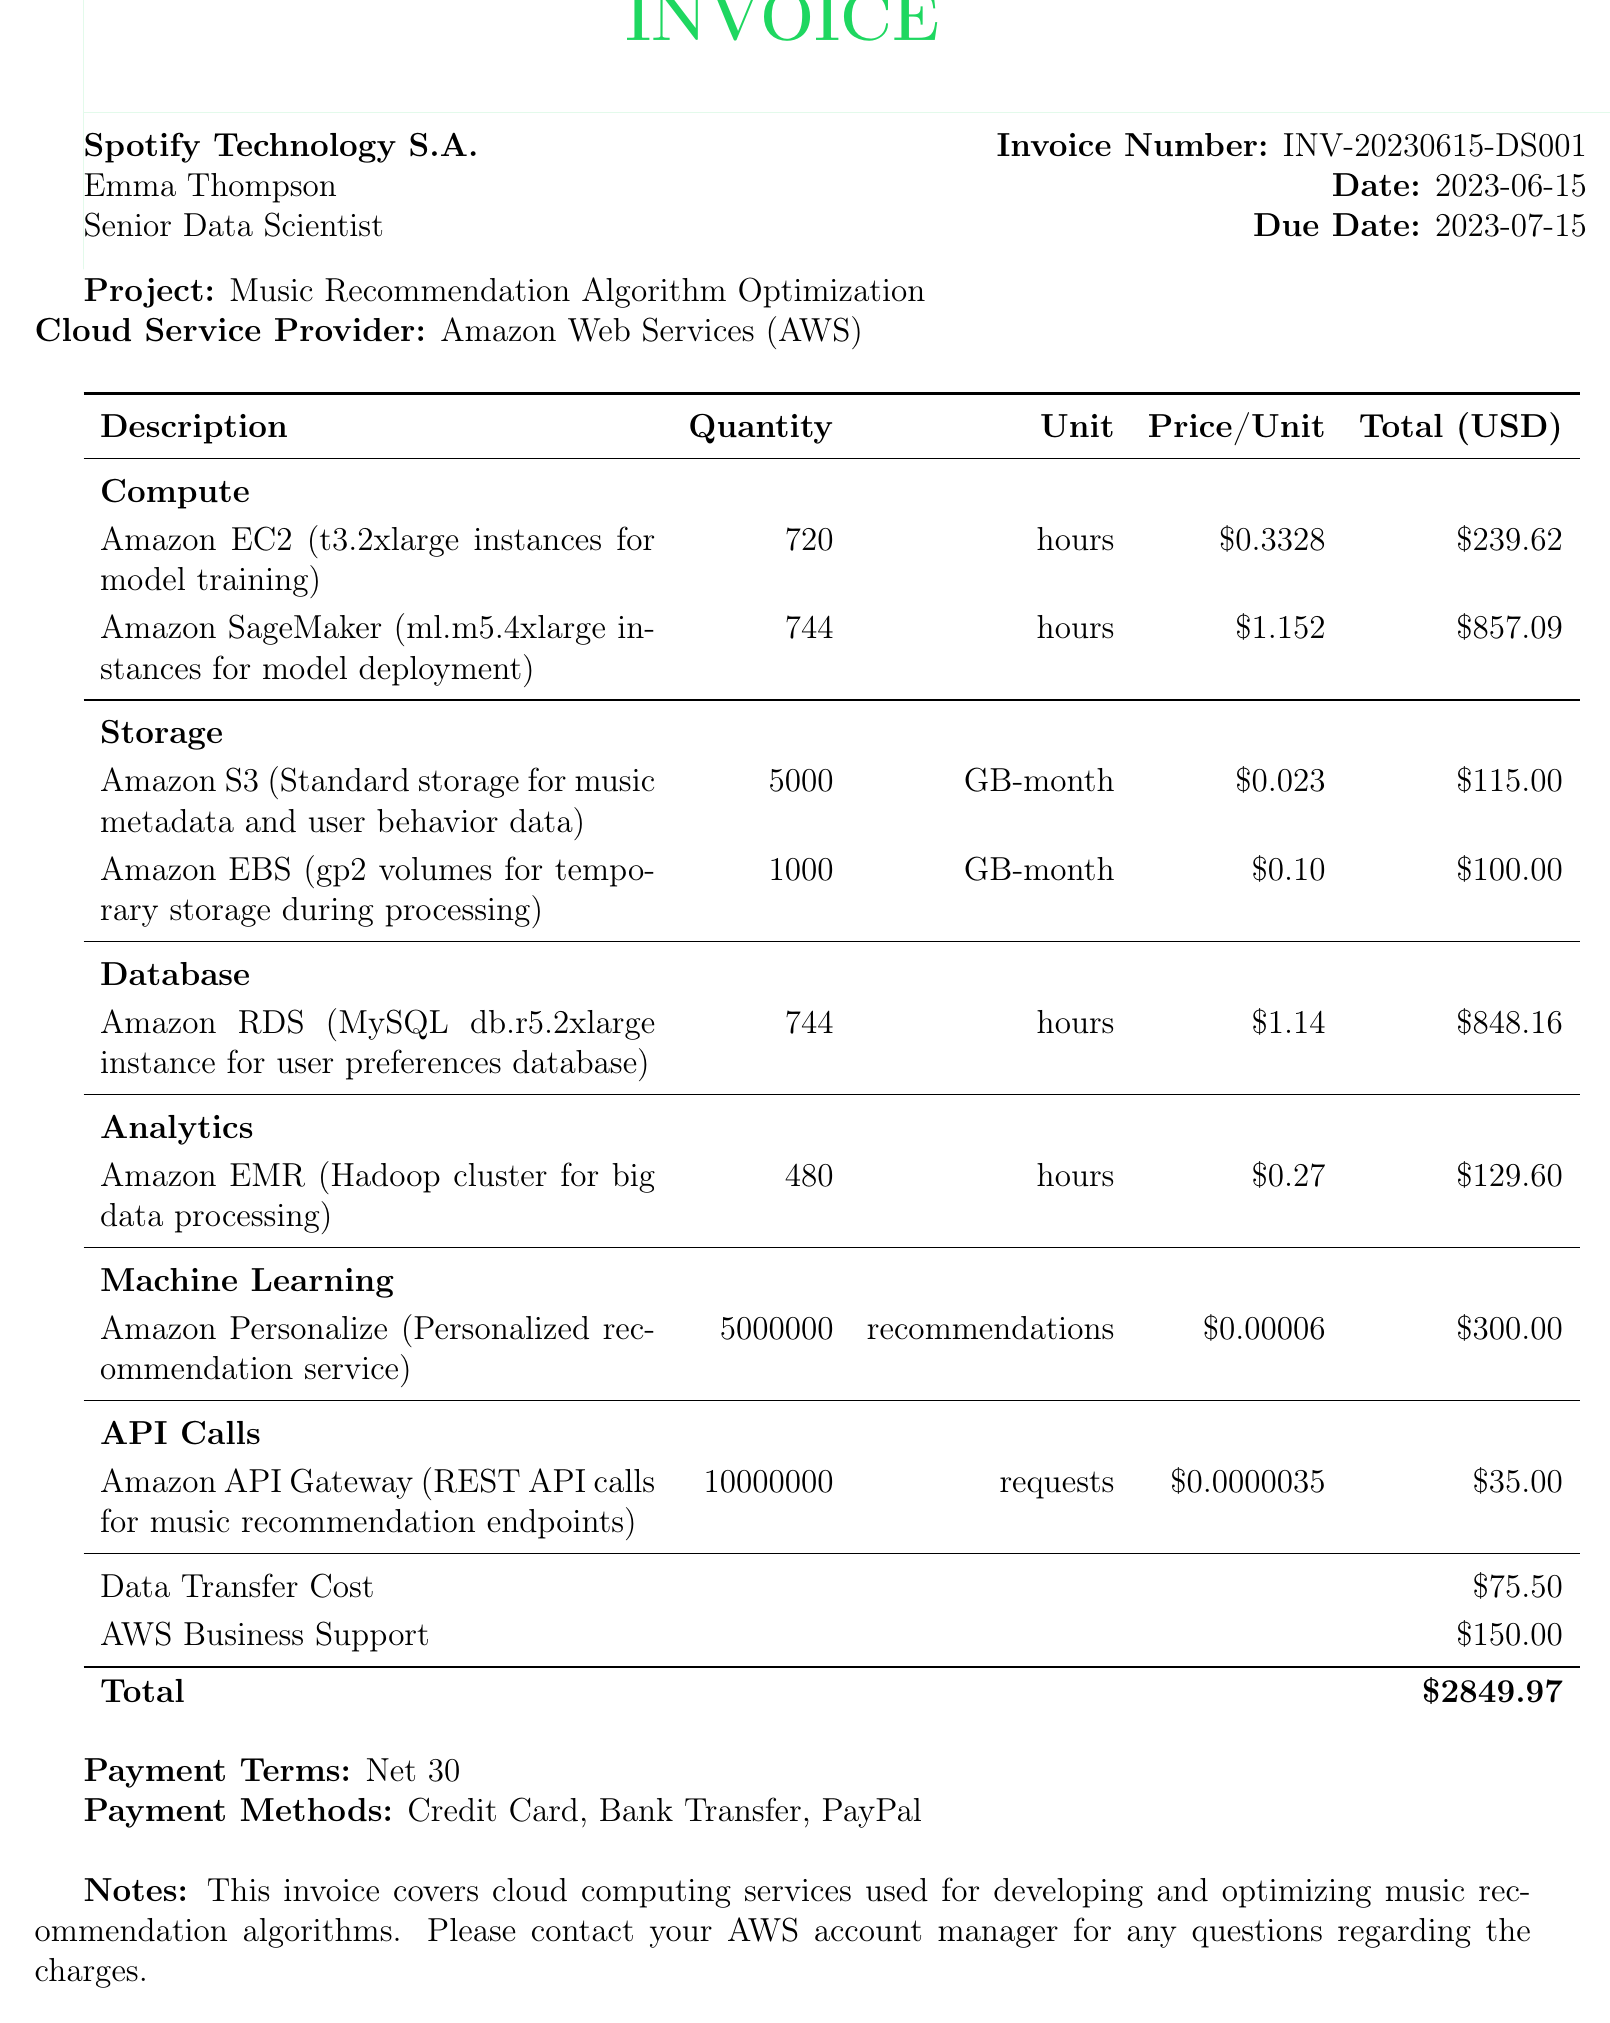what is the invoice number? The invoice number is specified in the document under the invoice details section.
Answer: INV-20230615-DS001 who is the client? The client's name is listed in the invoice details section.
Answer: Emma Thompson what is the total cost of the services? The total cost is summarized at the bottom of the invoice.
Answer: 2849.97 how many hours of Amazon EC2 instances were used for model training? The document specifies the quantity of hours for Amazon EC2 under the itemized costs section.
Answer: 720 what service is used for personalized recommendations? The document lists the specific service used for personalized recommendations in the machine learning category.
Answer: Amazon Personalize how much was spent on data transfer costs? Data transfer costs are listed separately in the additional details section of the invoice.
Answer: 75.50 what is the due date of the invoice? The due date is stated in the invoice details section of the document.
Answer: 2023-07-15 what support plan was included in the invoice? The support plan is mentioned in the additional details section of the invoice.
Answer: AWS Business Support how many recommendations were made using Amazon Personalize? The document specifies the quantity of recommendations in the machine learning item.
Answer: 5000000 